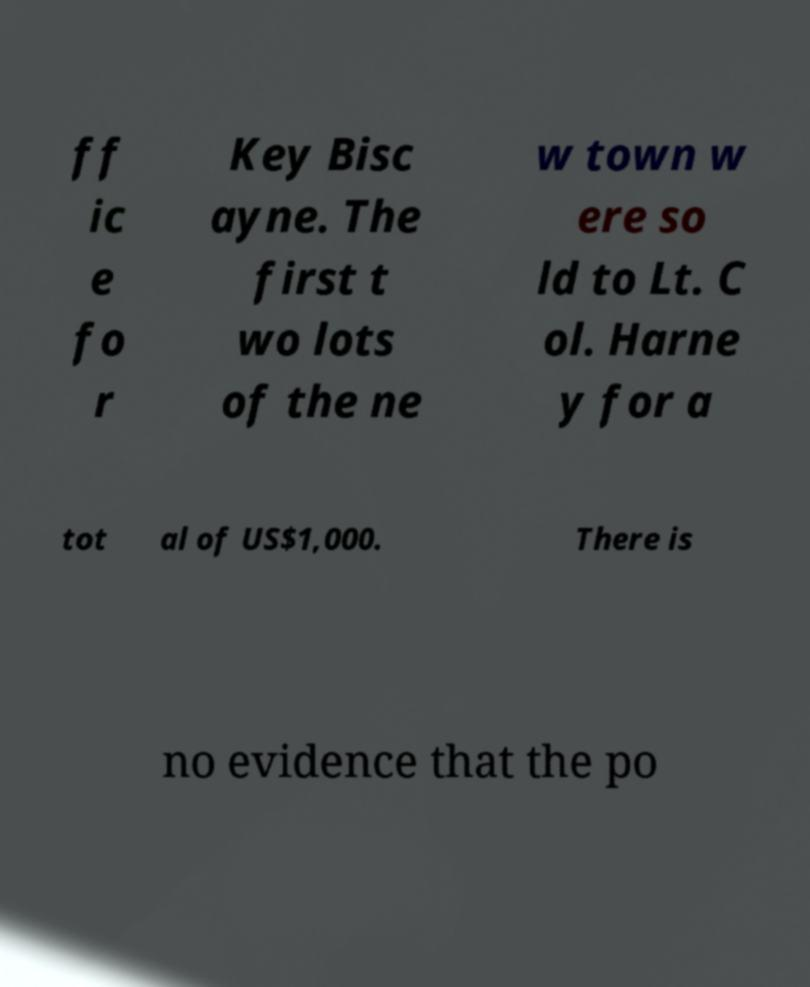Please identify and transcribe the text found in this image. ff ic e fo r Key Bisc ayne. The first t wo lots of the ne w town w ere so ld to Lt. C ol. Harne y for a tot al of US$1,000. There is no evidence that the po 